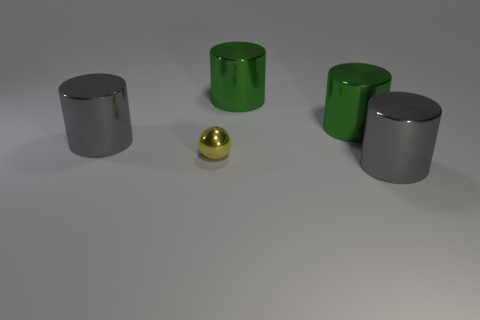Add 3 big purple matte cylinders. How many objects exist? 8 Subtract all spheres. How many objects are left? 4 Subtract 1 gray cylinders. How many objects are left? 4 Subtract all tiny things. Subtract all large gray metal things. How many objects are left? 2 Add 2 spheres. How many spheres are left? 3 Add 3 gray metallic things. How many gray metallic things exist? 5 